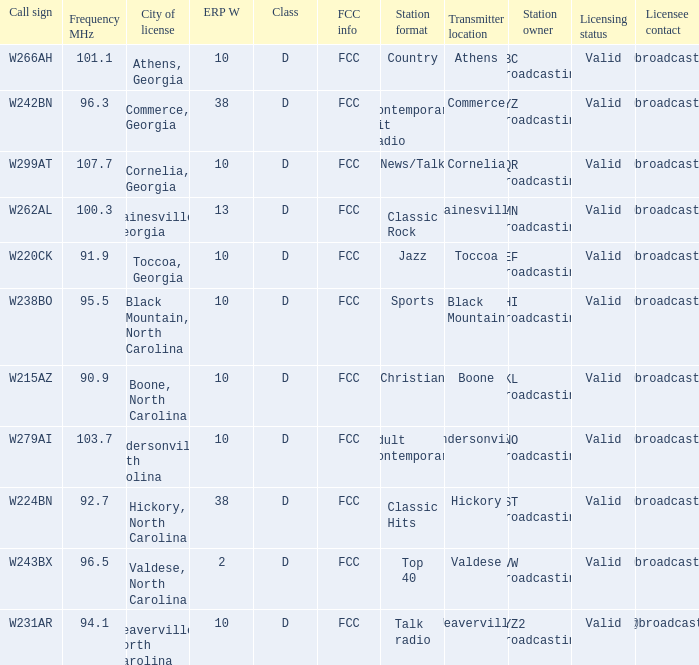What is the FCC frequency for the station w262al which has a Frequency MHz larger than 92.7? FCC. 